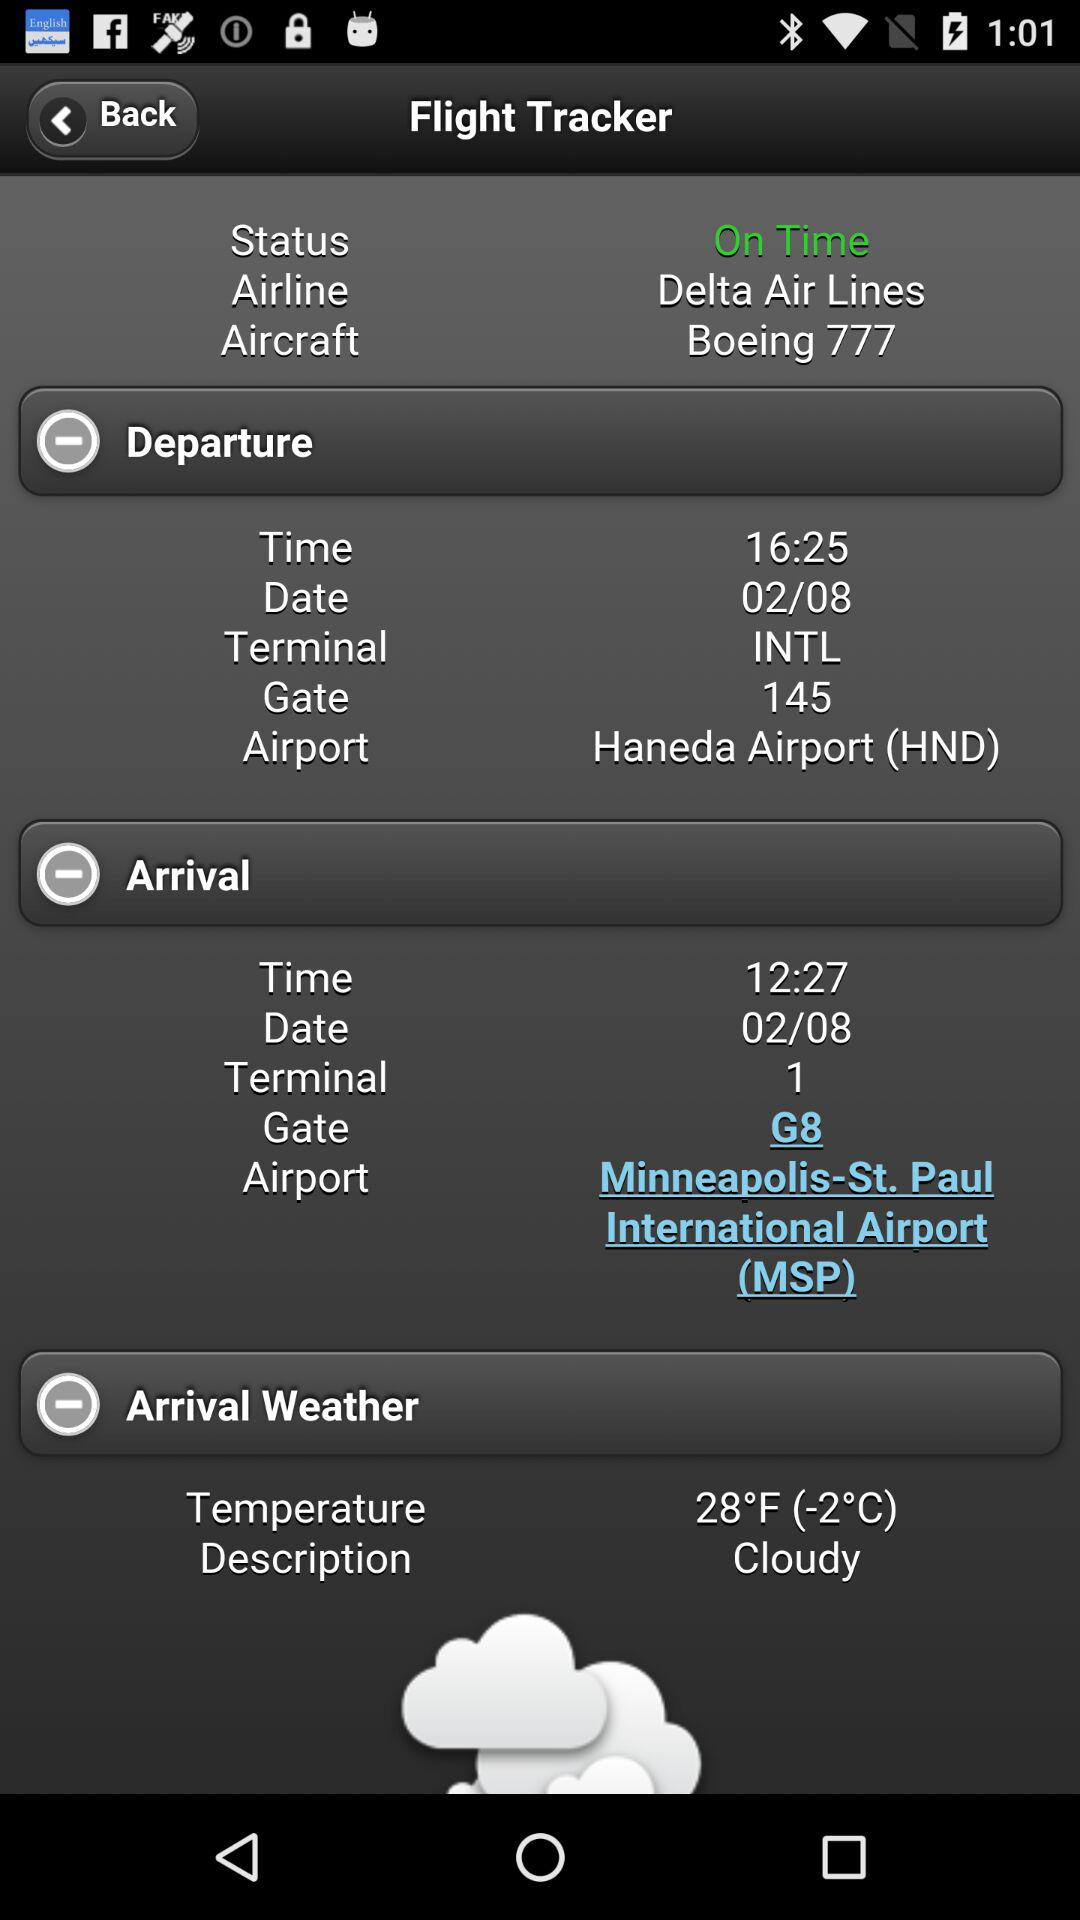What is the temperature? The temperature is 28°F (-2°C). 